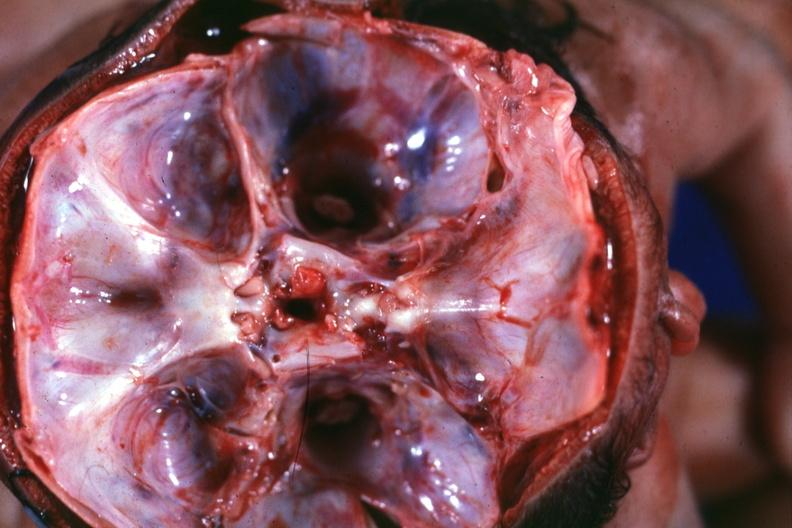what does this image show?
Answer the question using a single word or phrase. Opened skull looking into foramina magna single fused calvarium twins with separate brainstems 